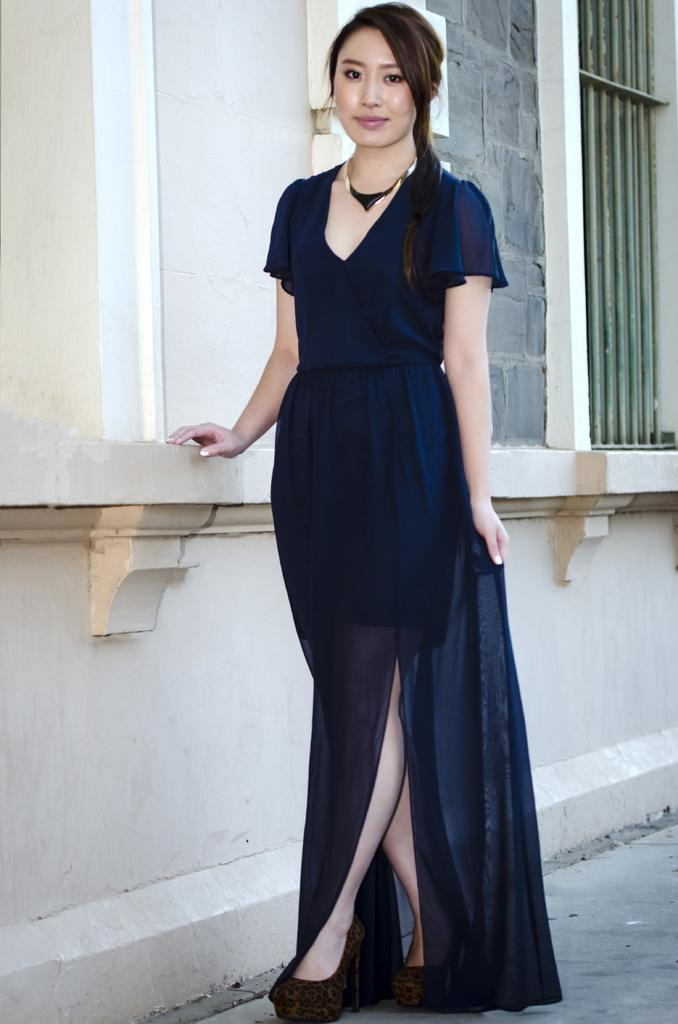Who is present in the image? There is a woman in the image. What is the woman doing in the image? The woman is standing. What is the woman wearing in the image? The woman is wearing a navy-blue color dress. What can be seen in the background of the image? There is a building and a window visible in the background of the image. What type of powder is being used by the woman in the image? There is no powder visible in the image, and the woman is not using any powder. What kind of toothbrush can be seen in the image? There is no toothbrush present in the image. 